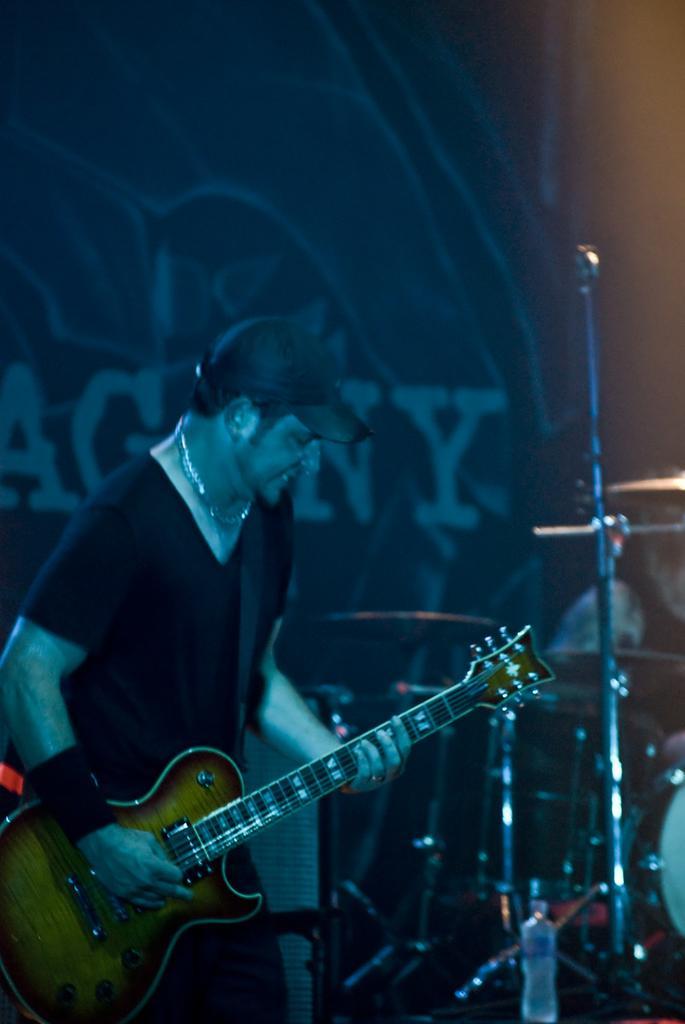Could you give a brief overview of what you see in this image? Man playing guitar wearing cap,here there are musical instruments. 